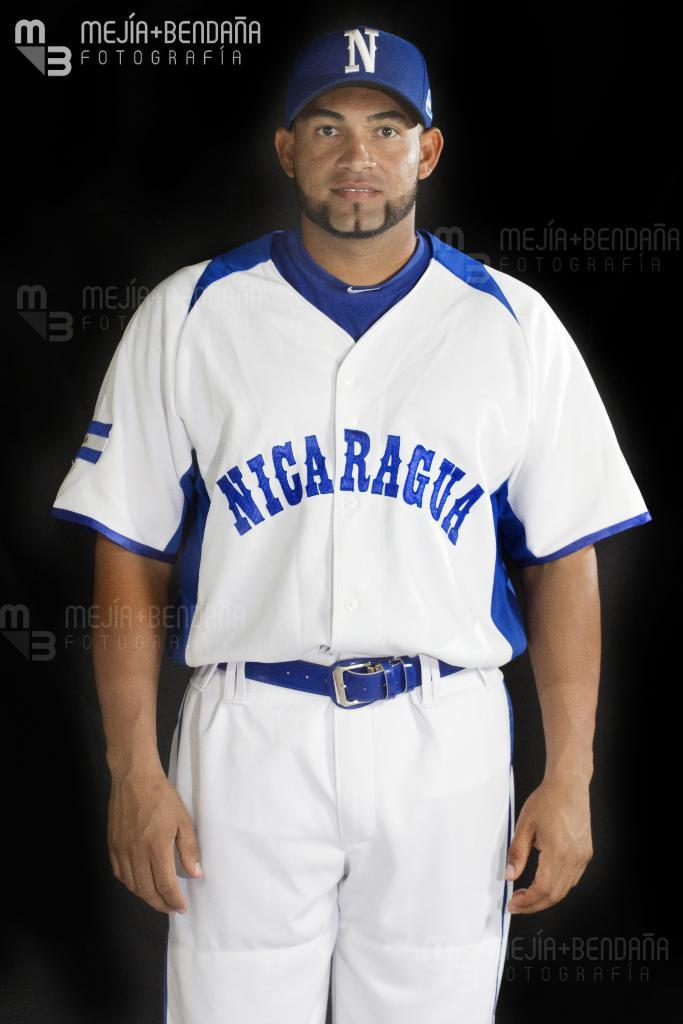<image>
Create a compact narrative representing the image presented. A man in a Nicaragua uniform wears a blue belt. 